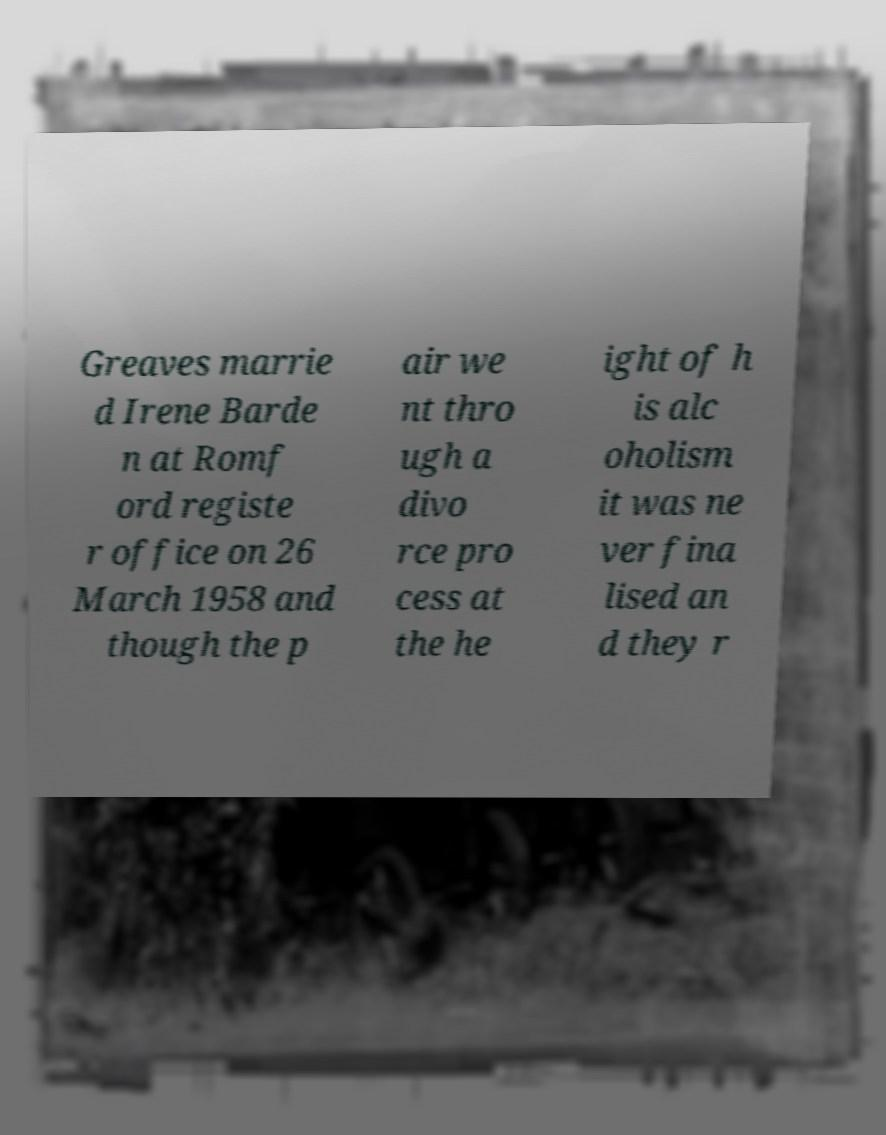Could you assist in decoding the text presented in this image and type it out clearly? Greaves marrie d Irene Barde n at Romf ord registe r office on 26 March 1958 and though the p air we nt thro ugh a divo rce pro cess at the he ight of h is alc oholism it was ne ver fina lised an d they r 